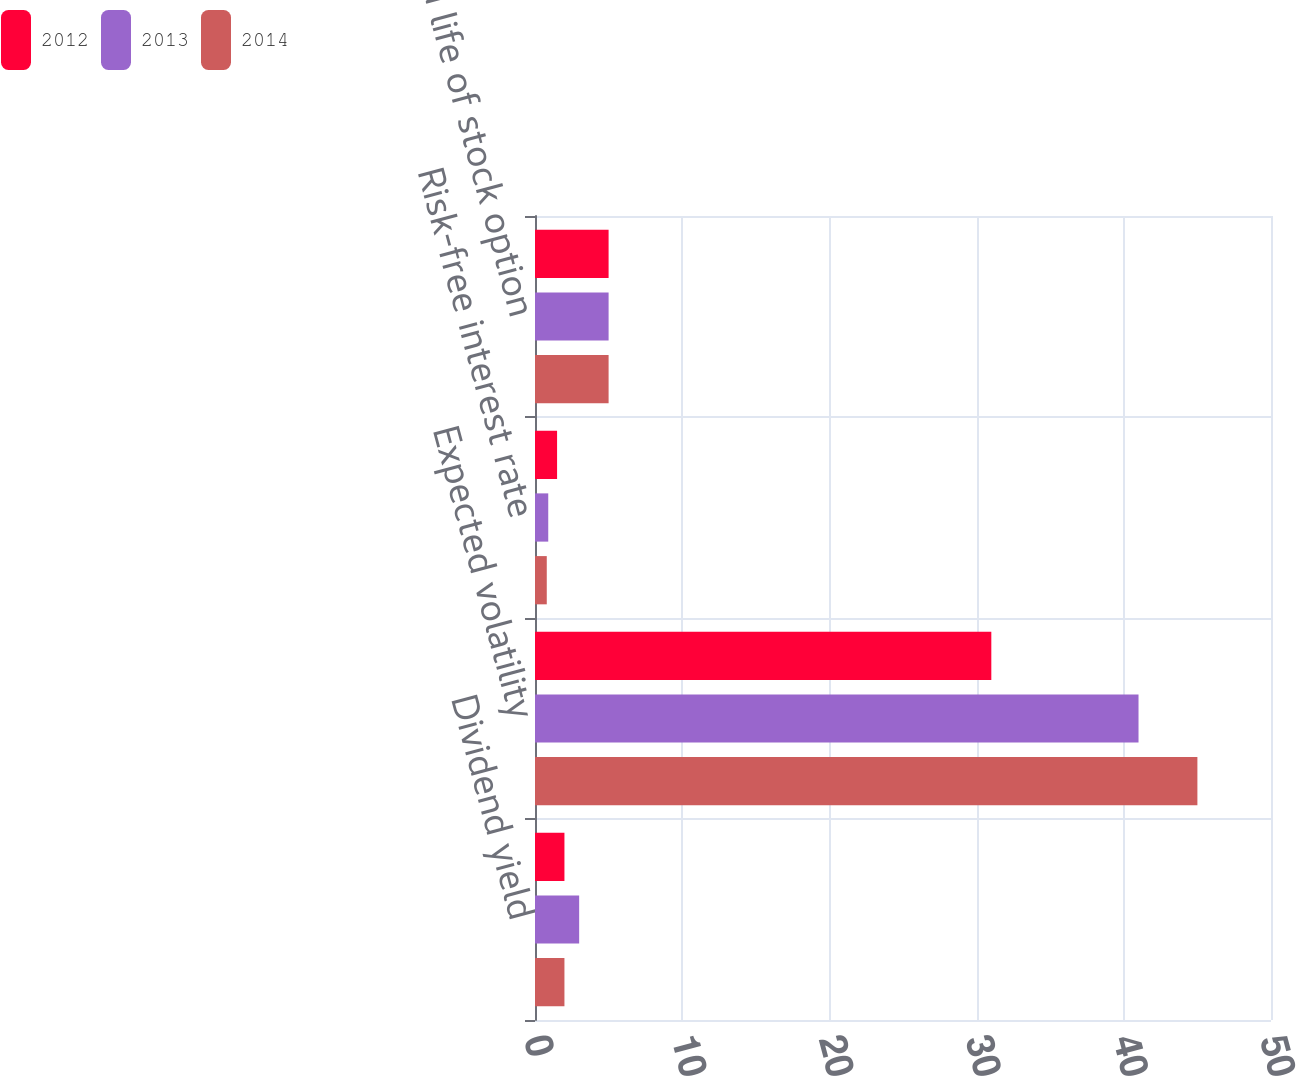Convert chart. <chart><loc_0><loc_0><loc_500><loc_500><stacked_bar_chart><ecel><fcel>Dividend yield<fcel>Expected volatility<fcel>Risk-free interest rate<fcel>Expected life of stock option<nl><fcel>2012<fcel>2<fcel>31<fcel>1.5<fcel>5<nl><fcel>2013<fcel>3<fcel>41<fcel>0.9<fcel>5<nl><fcel>2014<fcel>2<fcel>45<fcel>0.8<fcel>5<nl></chart> 